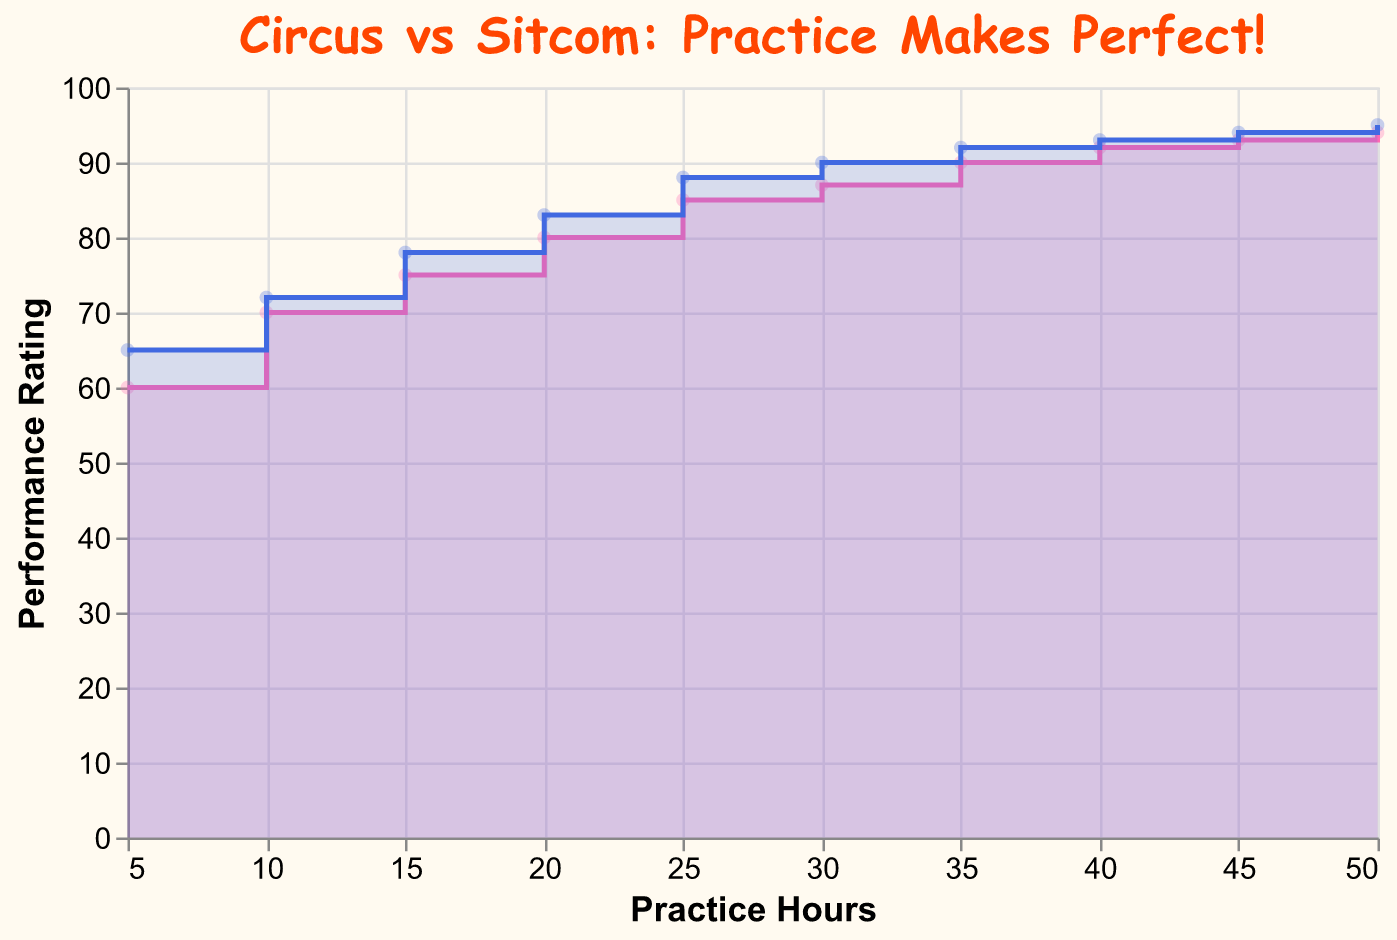What is the title of the chart? The title of the chart is displayed at the top and reads "Circus vs Sitcom: Practice Makes Perfect!"
Answer: Circus vs Sitcom: Practice Makes Perfect! How many practice hours correspond to a Circus Performance Rating of 85? By observing the chart, we can see that a Circus Performance Rating of 85 is achieved at 25 practice hours.
Answer: 25 At 10 practice hours, which performance rating is higher: Circus or Sitcom? Compare the y-values at the point where x (practice hours) is 10. The Circus Performance Rating is 70, whereas the Sitcom Performance Rating is 72, so the Sitcom rating is higher.
Answer: Sitcom What is the difference in Sitcom Performance Rating between 20 and 35 practice hours? Identify the Sitcom Performance Ratings at 20 and 35 practice hours which are 83 and 92 respectively, then compute the difference: 92 - 83 = 9.
Answer: 9 How does the Circus Performance Rating change as practice hours increase from 5 to 50? Review the plotted data points for Circus Performance Rating across the x-axis from 5 to 50 practice hours. The rating increases from 60 (5 hrs) to 94 (50 hrs).
Answer: Increases Which performance type (Circus or Sitcom) reaches a rating of 90 first in terms of practice hours? Look at both data series to determine the practice hours at which each reaches a rating of 90. The Circus reaches 90 rating at 35 hours, while the Sitcom reaches it at 30 hours. Therefore, Sitcom reaches it first.
Answer: Sitcom How many practice hours are required for Circus and Sitcom performances to surpass a rating of 90? Observing the chart, we see that the Circus reaches a rating of 90 at 35 hours, while the Sitcom reaches it at 30 hours.
Answer: 35 for Circus, 30 for Sitcom Describe the trend for Sitcom Performance Rating between 25 and 50 practice hours. Identify the points for Sitcom Performance Rating at 25 and 50 practice hours, which are 88 and 95 respectively. Notice the continuous increase between these values.
Answer: Increasing Compare the performance ratings at 30 practice hours for both Circus and Sitcom. Which is higher and by how much? Check the chart at 30 practice hours. Circus Performance Rating is 87, and Sitcom Performance Rating is 90. The Sitcom rating is higher by 90 - 87 = 3.
Answer: Sitcom by 3 Is there any point where the Circus Performance Rating is equal to the Sitcom Performance Rating between 5 and 50 practice hours? Scan across the two curves to see if there is any intersection. There are no points where the ratings are equal; the Sitcom rating is always higher.
Answer: No 